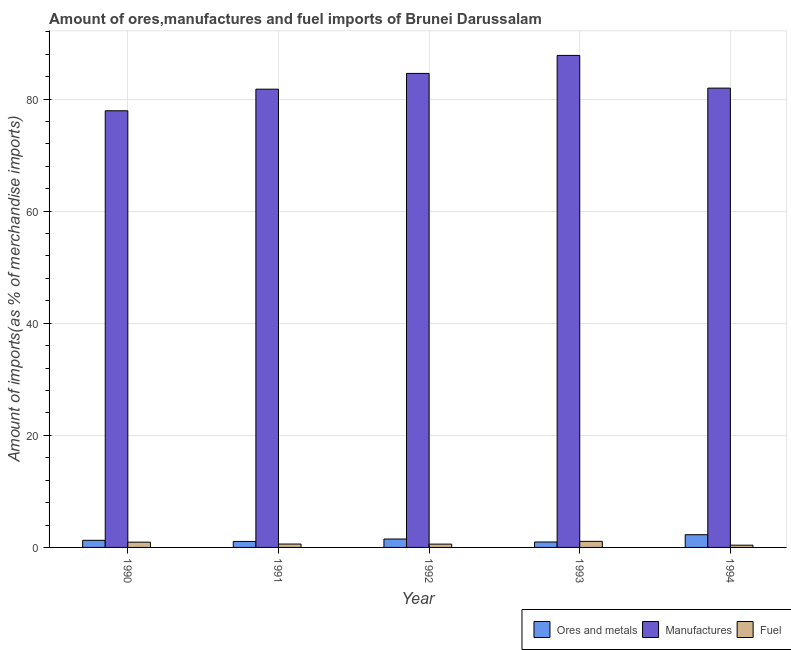How many groups of bars are there?
Offer a terse response. 5. How many bars are there on the 5th tick from the left?
Give a very brief answer. 3. What is the label of the 3rd group of bars from the left?
Make the answer very short. 1992. What is the percentage of fuel imports in 1994?
Offer a terse response. 0.4. Across all years, what is the maximum percentage of ores and metals imports?
Keep it short and to the point. 2.27. Across all years, what is the minimum percentage of fuel imports?
Ensure brevity in your answer.  0.4. In which year was the percentage of manufactures imports minimum?
Give a very brief answer. 1990. What is the total percentage of fuel imports in the graph?
Provide a succinct answer. 3.61. What is the difference between the percentage of fuel imports in 1991 and that in 1994?
Make the answer very short. 0.2. What is the difference between the percentage of manufactures imports in 1991 and the percentage of fuel imports in 1990?
Make the answer very short. 3.85. What is the average percentage of fuel imports per year?
Keep it short and to the point. 0.72. In how many years, is the percentage of manufactures imports greater than 44 %?
Make the answer very short. 5. What is the ratio of the percentage of manufactures imports in 1992 to that in 1993?
Your answer should be compact. 0.96. Is the percentage of manufactures imports in 1990 less than that in 1994?
Offer a terse response. Yes. Is the difference between the percentage of fuel imports in 1992 and 1993 greater than the difference between the percentage of manufactures imports in 1992 and 1993?
Your answer should be compact. No. What is the difference between the highest and the second highest percentage of fuel imports?
Your response must be concise. 0.14. What is the difference between the highest and the lowest percentage of fuel imports?
Provide a short and direct response. 0.68. In how many years, is the percentage of manufactures imports greater than the average percentage of manufactures imports taken over all years?
Make the answer very short. 2. Is the sum of the percentage of manufactures imports in 1990 and 1991 greater than the maximum percentage of ores and metals imports across all years?
Make the answer very short. Yes. What does the 1st bar from the left in 1994 represents?
Your answer should be compact. Ores and metals. What does the 1st bar from the right in 1993 represents?
Make the answer very short. Fuel. How many bars are there?
Provide a short and direct response. 15. How many years are there in the graph?
Make the answer very short. 5. What is the difference between two consecutive major ticks on the Y-axis?
Offer a very short reply. 20. Are the values on the major ticks of Y-axis written in scientific E-notation?
Offer a very short reply. No. What is the title of the graph?
Your answer should be compact. Amount of ores,manufactures and fuel imports of Brunei Darussalam. Does "Taxes on international trade" appear as one of the legend labels in the graph?
Your answer should be compact. No. What is the label or title of the Y-axis?
Offer a terse response. Amount of imports(as % of merchandise imports). What is the Amount of imports(as % of merchandise imports) of Ores and metals in 1990?
Make the answer very short. 1.27. What is the Amount of imports(as % of merchandise imports) of Manufactures in 1990?
Make the answer very short. 77.91. What is the Amount of imports(as % of merchandise imports) in Fuel in 1990?
Offer a terse response. 0.94. What is the Amount of imports(as % of merchandise imports) in Ores and metals in 1991?
Provide a succinct answer. 1.07. What is the Amount of imports(as % of merchandise imports) of Manufactures in 1991?
Offer a very short reply. 81.76. What is the Amount of imports(as % of merchandise imports) of Fuel in 1991?
Offer a very short reply. 0.6. What is the Amount of imports(as % of merchandise imports) in Ores and metals in 1992?
Your answer should be compact. 1.5. What is the Amount of imports(as % of merchandise imports) of Manufactures in 1992?
Keep it short and to the point. 84.58. What is the Amount of imports(as % of merchandise imports) in Fuel in 1992?
Keep it short and to the point. 0.59. What is the Amount of imports(as % of merchandise imports) in Ores and metals in 1993?
Give a very brief answer. 0.97. What is the Amount of imports(as % of merchandise imports) in Manufactures in 1993?
Ensure brevity in your answer.  87.79. What is the Amount of imports(as % of merchandise imports) in Fuel in 1993?
Your answer should be compact. 1.08. What is the Amount of imports(as % of merchandise imports) in Ores and metals in 1994?
Ensure brevity in your answer.  2.27. What is the Amount of imports(as % of merchandise imports) of Manufactures in 1994?
Offer a very short reply. 81.95. What is the Amount of imports(as % of merchandise imports) in Fuel in 1994?
Your answer should be compact. 0.4. Across all years, what is the maximum Amount of imports(as % of merchandise imports) in Ores and metals?
Your response must be concise. 2.27. Across all years, what is the maximum Amount of imports(as % of merchandise imports) in Manufactures?
Provide a succinct answer. 87.79. Across all years, what is the maximum Amount of imports(as % of merchandise imports) in Fuel?
Offer a terse response. 1.08. Across all years, what is the minimum Amount of imports(as % of merchandise imports) of Ores and metals?
Keep it short and to the point. 0.97. Across all years, what is the minimum Amount of imports(as % of merchandise imports) of Manufactures?
Provide a succinct answer. 77.91. Across all years, what is the minimum Amount of imports(as % of merchandise imports) in Fuel?
Keep it short and to the point. 0.4. What is the total Amount of imports(as % of merchandise imports) in Ores and metals in the graph?
Your response must be concise. 7.08. What is the total Amount of imports(as % of merchandise imports) in Manufactures in the graph?
Keep it short and to the point. 413.99. What is the total Amount of imports(as % of merchandise imports) of Fuel in the graph?
Ensure brevity in your answer.  3.61. What is the difference between the Amount of imports(as % of merchandise imports) in Ores and metals in 1990 and that in 1991?
Offer a terse response. 0.2. What is the difference between the Amount of imports(as % of merchandise imports) of Manufactures in 1990 and that in 1991?
Offer a very short reply. -3.85. What is the difference between the Amount of imports(as % of merchandise imports) of Fuel in 1990 and that in 1991?
Provide a succinct answer. 0.33. What is the difference between the Amount of imports(as % of merchandise imports) of Ores and metals in 1990 and that in 1992?
Offer a terse response. -0.24. What is the difference between the Amount of imports(as % of merchandise imports) of Manufactures in 1990 and that in 1992?
Ensure brevity in your answer.  -6.67. What is the difference between the Amount of imports(as % of merchandise imports) in Fuel in 1990 and that in 1992?
Ensure brevity in your answer.  0.35. What is the difference between the Amount of imports(as % of merchandise imports) in Ores and metals in 1990 and that in 1993?
Provide a succinct answer. 0.3. What is the difference between the Amount of imports(as % of merchandise imports) in Manufactures in 1990 and that in 1993?
Offer a very short reply. -9.88. What is the difference between the Amount of imports(as % of merchandise imports) in Fuel in 1990 and that in 1993?
Make the answer very short. -0.14. What is the difference between the Amount of imports(as % of merchandise imports) of Ores and metals in 1990 and that in 1994?
Provide a succinct answer. -1. What is the difference between the Amount of imports(as % of merchandise imports) in Manufactures in 1990 and that in 1994?
Your answer should be compact. -4.04. What is the difference between the Amount of imports(as % of merchandise imports) in Fuel in 1990 and that in 1994?
Your response must be concise. 0.54. What is the difference between the Amount of imports(as % of merchandise imports) of Ores and metals in 1991 and that in 1992?
Your answer should be very brief. -0.44. What is the difference between the Amount of imports(as % of merchandise imports) of Manufactures in 1991 and that in 1992?
Ensure brevity in your answer.  -2.81. What is the difference between the Amount of imports(as % of merchandise imports) in Fuel in 1991 and that in 1992?
Give a very brief answer. 0.01. What is the difference between the Amount of imports(as % of merchandise imports) of Ores and metals in 1991 and that in 1993?
Your response must be concise. 0.1. What is the difference between the Amount of imports(as % of merchandise imports) in Manufactures in 1991 and that in 1993?
Offer a terse response. -6.02. What is the difference between the Amount of imports(as % of merchandise imports) of Fuel in 1991 and that in 1993?
Your response must be concise. -0.48. What is the difference between the Amount of imports(as % of merchandise imports) in Ores and metals in 1991 and that in 1994?
Your answer should be compact. -1.2. What is the difference between the Amount of imports(as % of merchandise imports) of Manufactures in 1991 and that in 1994?
Offer a very short reply. -0.19. What is the difference between the Amount of imports(as % of merchandise imports) of Fuel in 1991 and that in 1994?
Offer a terse response. 0.2. What is the difference between the Amount of imports(as % of merchandise imports) in Ores and metals in 1992 and that in 1993?
Give a very brief answer. 0.53. What is the difference between the Amount of imports(as % of merchandise imports) of Manufactures in 1992 and that in 1993?
Ensure brevity in your answer.  -3.21. What is the difference between the Amount of imports(as % of merchandise imports) of Fuel in 1992 and that in 1993?
Your answer should be very brief. -0.49. What is the difference between the Amount of imports(as % of merchandise imports) in Ores and metals in 1992 and that in 1994?
Your answer should be very brief. -0.76. What is the difference between the Amount of imports(as % of merchandise imports) in Manufactures in 1992 and that in 1994?
Give a very brief answer. 2.62. What is the difference between the Amount of imports(as % of merchandise imports) in Fuel in 1992 and that in 1994?
Your answer should be very brief. 0.19. What is the difference between the Amount of imports(as % of merchandise imports) in Ores and metals in 1993 and that in 1994?
Provide a short and direct response. -1.3. What is the difference between the Amount of imports(as % of merchandise imports) of Manufactures in 1993 and that in 1994?
Give a very brief answer. 5.83. What is the difference between the Amount of imports(as % of merchandise imports) of Fuel in 1993 and that in 1994?
Keep it short and to the point. 0.68. What is the difference between the Amount of imports(as % of merchandise imports) of Ores and metals in 1990 and the Amount of imports(as % of merchandise imports) of Manufactures in 1991?
Your response must be concise. -80.49. What is the difference between the Amount of imports(as % of merchandise imports) in Ores and metals in 1990 and the Amount of imports(as % of merchandise imports) in Fuel in 1991?
Keep it short and to the point. 0.66. What is the difference between the Amount of imports(as % of merchandise imports) of Manufactures in 1990 and the Amount of imports(as % of merchandise imports) of Fuel in 1991?
Offer a terse response. 77.31. What is the difference between the Amount of imports(as % of merchandise imports) in Ores and metals in 1990 and the Amount of imports(as % of merchandise imports) in Manufactures in 1992?
Your response must be concise. -83.31. What is the difference between the Amount of imports(as % of merchandise imports) in Ores and metals in 1990 and the Amount of imports(as % of merchandise imports) in Fuel in 1992?
Offer a very short reply. 0.68. What is the difference between the Amount of imports(as % of merchandise imports) in Manufactures in 1990 and the Amount of imports(as % of merchandise imports) in Fuel in 1992?
Offer a very short reply. 77.32. What is the difference between the Amount of imports(as % of merchandise imports) in Ores and metals in 1990 and the Amount of imports(as % of merchandise imports) in Manufactures in 1993?
Your response must be concise. -86.52. What is the difference between the Amount of imports(as % of merchandise imports) in Ores and metals in 1990 and the Amount of imports(as % of merchandise imports) in Fuel in 1993?
Provide a short and direct response. 0.19. What is the difference between the Amount of imports(as % of merchandise imports) of Manufactures in 1990 and the Amount of imports(as % of merchandise imports) of Fuel in 1993?
Provide a succinct answer. 76.83. What is the difference between the Amount of imports(as % of merchandise imports) of Ores and metals in 1990 and the Amount of imports(as % of merchandise imports) of Manufactures in 1994?
Provide a short and direct response. -80.68. What is the difference between the Amount of imports(as % of merchandise imports) in Ores and metals in 1990 and the Amount of imports(as % of merchandise imports) in Fuel in 1994?
Offer a very short reply. 0.87. What is the difference between the Amount of imports(as % of merchandise imports) in Manufactures in 1990 and the Amount of imports(as % of merchandise imports) in Fuel in 1994?
Your answer should be very brief. 77.51. What is the difference between the Amount of imports(as % of merchandise imports) in Ores and metals in 1991 and the Amount of imports(as % of merchandise imports) in Manufactures in 1992?
Your answer should be compact. -83.51. What is the difference between the Amount of imports(as % of merchandise imports) in Ores and metals in 1991 and the Amount of imports(as % of merchandise imports) in Fuel in 1992?
Provide a short and direct response. 0.48. What is the difference between the Amount of imports(as % of merchandise imports) of Manufactures in 1991 and the Amount of imports(as % of merchandise imports) of Fuel in 1992?
Provide a succinct answer. 81.17. What is the difference between the Amount of imports(as % of merchandise imports) of Ores and metals in 1991 and the Amount of imports(as % of merchandise imports) of Manufactures in 1993?
Keep it short and to the point. -86.72. What is the difference between the Amount of imports(as % of merchandise imports) in Ores and metals in 1991 and the Amount of imports(as % of merchandise imports) in Fuel in 1993?
Your answer should be very brief. -0.01. What is the difference between the Amount of imports(as % of merchandise imports) of Manufactures in 1991 and the Amount of imports(as % of merchandise imports) of Fuel in 1993?
Offer a terse response. 80.68. What is the difference between the Amount of imports(as % of merchandise imports) of Ores and metals in 1991 and the Amount of imports(as % of merchandise imports) of Manufactures in 1994?
Give a very brief answer. -80.89. What is the difference between the Amount of imports(as % of merchandise imports) of Ores and metals in 1991 and the Amount of imports(as % of merchandise imports) of Fuel in 1994?
Offer a terse response. 0.66. What is the difference between the Amount of imports(as % of merchandise imports) of Manufactures in 1991 and the Amount of imports(as % of merchandise imports) of Fuel in 1994?
Give a very brief answer. 81.36. What is the difference between the Amount of imports(as % of merchandise imports) of Ores and metals in 1992 and the Amount of imports(as % of merchandise imports) of Manufactures in 1993?
Your answer should be compact. -86.28. What is the difference between the Amount of imports(as % of merchandise imports) in Ores and metals in 1992 and the Amount of imports(as % of merchandise imports) in Fuel in 1993?
Make the answer very short. 0.42. What is the difference between the Amount of imports(as % of merchandise imports) in Manufactures in 1992 and the Amount of imports(as % of merchandise imports) in Fuel in 1993?
Your answer should be very brief. 83.49. What is the difference between the Amount of imports(as % of merchandise imports) of Ores and metals in 1992 and the Amount of imports(as % of merchandise imports) of Manufactures in 1994?
Make the answer very short. -80.45. What is the difference between the Amount of imports(as % of merchandise imports) of Ores and metals in 1992 and the Amount of imports(as % of merchandise imports) of Fuel in 1994?
Make the answer very short. 1.1. What is the difference between the Amount of imports(as % of merchandise imports) in Manufactures in 1992 and the Amount of imports(as % of merchandise imports) in Fuel in 1994?
Provide a succinct answer. 84.17. What is the difference between the Amount of imports(as % of merchandise imports) of Ores and metals in 1993 and the Amount of imports(as % of merchandise imports) of Manufactures in 1994?
Keep it short and to the point. -80.98. What is the difference between the Amount of imports(as % of merchandise imports) in Ores and metals in 1993 and the Amount of imports(as % of merchandise imports) in Fuel in 1994?
Offer a very short reply. 0.57. What is the difference between the Amount of imports(as % of merchandise imports) in Manufactures in 1993 and the Amount of imports(as % of merchandise imports) in Fuel in 1994?
Give a very brief answer. 87.38. What is the average Amount of imports(as % of merchandise imports) of Ores and metals per year?
Offer a very short reply. 1.42. What is the average Amount of imports(as % of merchandise imports) in Manufactures per year?
Ensure brevity in your answer.  82.8. What is the average Amount of imports(as % of merchandise imports) of Fuel per year?
Make the answer very short. 0.72. In the year 1990, what is the difference between the Amount of imports(as % of merchandise imports) of Ores and metals and Amount of imports(as % of merchandise imports) of Manufactures?
Ensure brevity in your answer.  -76.64. In the year 1990, what is the difference between the Amount of imports(as % of merchandise imports) in Ores and metals and Amount of imports(as % of merchandise imports) in Fuel?
Offer a terse response. 0.33. In the year 1990, what is the difference between the Amount of imports(as % of merchandise imports) in Manufactures and Amount of imports(as % of merchandise imports) in Fuel?
Your response must be concise. 76.97. In the year 1991, what is the difference between the Amount of imports(as % of merchandise imports) in Ores and metals and Amount of imports(as % of merchandise imports) in Manufactures?
Make the answer very short. -80.7. In the year 1991, what is the difference between the Amount of imports(as % of merchandise imports) of Ores and metals and Amount of imports(as % of merchandise imports) of Fuel?
Provide a short and direct response. 0.46. In the year 1991, what is the difference between the Amount of imports(as % of merchandise imports) in Manufactures and Amount of imports(as % of merchandise imports) in Fuel?
Make the answer very short. 81.16. In the year 1992, what is the difference between the Amount of imports(as % of merchandise imports) of Ores and metals and Amount of imports(as % of merchandise imports) of Manufactures?
Provide a succinct answer. -83.07. In the year 1992, what is the difference between the Amount of imports(as % of merchandise imports) of Ores and metals and Amount of imports(as % of merchandise imports) of Fuel?
Offer a very short reply. 0.91. In the year 1992, what is the difference between the Amount of imports(as % of merchandise imports) of Manufactures and Amount of imports(as % of merchandise imports) of Fuel?
Offer a very short reply. 83.99. In the year 1993, what is the difference between the Amount of imports(as % of merchandise imports) in Ores and metals and Amount of imports(as % of merchandise imports) in Manufactures?
Your response must be concise. -86.82. In the year 1993, what is the difference between the Amount of imports(as % of merchandise imports) of Ores and metals and Amount of imports(as % of merchandise imports) of Fuel?
Keep it short and to the point. -0.11. In the year 1993, what is the difference between the Amount of imports(as % of merchandise imports) of Manufactures and Amount of imports(as % of merchandise imports) of Fuel?
Provide a short and direct response. 86.71. In the year 1994, what is the difference between the Amount of imports(as % of merchandise imports) in Ores and metals and Amount of imports(as % of merchandise imports) in Manufactures?
Offer a very short reply. -79.68. In the year 1994, what is the difference between the Amount of imports(as % of merchandise imports) of Ores and metals and Amount of imports(as % of merchandise imports) of Fuel?
Your answer should be very brief. 1.87. In the year 1994, what is the difference between the Amount of imports(as % of merchandise imports) in Manufactures and Amount of imports(as % of merchandise imports) in Fuel?
Make the answer very short. 81.55. What is the ratio of the Amount of imports(as % of merchandise imports) of Ores and metals in 1990 to that in 1991?
Ensure brevity in your answer.  1.19. What is the ratio of the Amount of imports(as % of merchandise imports) in Manufactures in 1990 to that in 1991?
Provide a succinct answer. 0.95. What is the ratio of the Amount of imports(as % of merchandise imports) in Fuel in 1990 to that in 1991?
Make the answer very short. 1.55. What is the ratio of the Amount of imports(as % of merchandise imports) of Ores and metals in 1990 to that in 1992?
Offer a very short reply. 0.84. What is the ratio of the Amount of imports(as % of merchandise imports) of Manufactures in 1990 to that in 1992?
Your answer should be compact. 0.92. What is the ratio of the Amount of imports(as % of merchandise imports) in Fuel in 1990 to that in 1992?
Provide a succinct answer. 1.59. What is the ratio of the Amount of imports(as % of merchandise imports) of Ores and metals in 1990 to that in 1993?
Ensure brevity in your answer.  1.31. What is the ratio of the Amount of imports(as % of merchandise imports) in Manufactures in 1990 to that in 1993?
Your answer should be very brief. 0.89. What is the ratio of the Amount of imports(as % of merchandise imports) of Fuel in 1990 to that in 1993?
Ensure brevity in your answer.  0.87. What is the ratio of the Amount of imports(as % of merchandise imports) of Ores and metals in 1990 to that in 1994?
Ensure brevity in your answer.  0.56. What is the ratio of the Amount of imports(as % of merchandise imports) of Manufactures in 1990 to that in 1994?
Offer a terse response. 0.95. What is the ratio of the Amount of imports(as % of merchandise imports) of Fuel in 1990 to that in 1994?
Give a very brief answer. 2.33. What is the ratio of the Amount of imports(as % of merchandise imports) in Ores and metals in 1991 to that in 1992?
Offer a terse response. 0.71. What is the ratio of the Amount of imports(as % of merchandise imports) in Manufactures in 1991 to that in 1992?
Offer a terse response. 0.97. What is the ratio of the Amount of imports(as % of merchandise imports) of Fuel in 1991 to that in 1992?
Make the answer very short. 1.02. What is the ratio of the Amount of imports(as % of merchandise imports) in Ores and metals in 1991 to that in 1993?
Keep it short and to the point. 1.1. What is the ratio of the Amount of imports(as % of merchandise imports) of Manufactures in 1991 to that in 1993?
Keep it short and to the point. 0.93. What is the ratio of the Amount of imports(as % of merchandise imports) in Fuel in 1991 to that in 1993?
Give a very brief answer. 0.56. What is the ratio of the Amount of imports(as % of merchandise imports) in Ores and metals in 1991 to that in 1994?
Offer a terse response. 0.47. What is the ratio of the Amount of imports(as % of merchandise imports) in Manufactures in 1991 to that in 1994?
Your answer should be very brief. 1. What is the ratio of the Amount of imports(as % of merchandise imports) in Fuel in 1991 to that in 1994?
Ensure brevity in your answer.  1.5. What is the ratio of the Amount of imports(as % of merchandise imports) in Ores and metals in 1992 to that in 1993?
Your answer should be compact. 1.55. What is the ratio of the Amount of imports(as % of merchandise imports) of Manufactures in 1992 to that in 1993?
Give a very brief answer. 0.96. What is the ratio of the Amount of imports(as % of merchandise imports) of Fuel in 1992 to that in 1993?
Offer a very short reply. 0.55. What is the ratio of the Amount of imports(as % of merchandise imports) of Ores and metals in 1992 to that in 1994?
Your response must be concise. 0.66. What is the ratio of the Amount of imports(as % of merchandise imports) of Manufactures in 1992 to that in 1994?
Your answer should be compact. 1.03. What is the ratio of the Amount of imports(as % of merchandise imports) in Fuel in 1992 to that in 1994?
Provide a short and direct response. 1.47. What is the ratio of the Amount of imports(as % of merchandise imports) in Ores and metals in 1993 to that in 1994?
Provide a succinct answer. 0.43. What is the ratio of the Amount of imports(as % of merchandise imports) of Manufactures in 1993 to that in 1994?
Ensure brevity in your answer.  1.07. What is the ratio of the Amount of imports(as % of merchandise imports) of Fuel in 1993 to that in 1994?
Keep it short and to the point. 2.69. What is the difference between the highest and the second highest Amount of imports(as % of merchandise imports) in Ores and metals?
Your answer should be compact. 0.76. What is the difference between the highest and the second highest Amount of imports(as % of merchandise imports) of Manufactures?
Your answer should be very brief. 3.21. What is the difference between the highest and the second highest Amount of imports(as % of merchandise imports) in Fuel?
Keep it short and to the point. 0.14. What is the difference between the highest and the lowest Amount of imports(as % of merchandise imports) of Ores and metals?
Make the answer very short. 1.3. What is the difference between the highest and the lowest Amount of imports(as % of merchandise imports) of Manufactures?
Ensure brevity in your answer.  9.88. What is the difference between the highest and the lowest Amount of imports(as % of merchandise imports) of Fuel?
Make the answer very short. 0.68. 